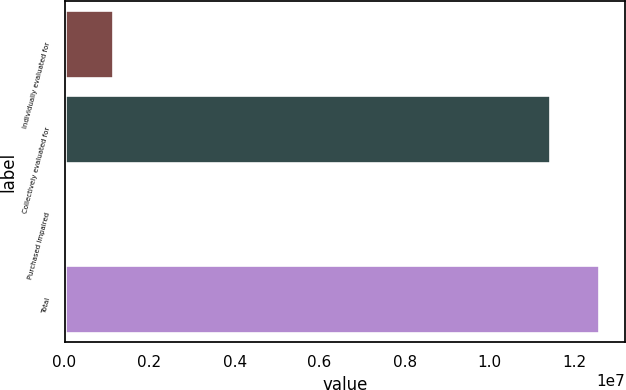Convert chart. <chart><loc_0><loc_0><loc_500><loc_500><bar_chart><fcel>Individually evaluated for<fcel>Collectively evaluated for<fcel>Purchased impaired<fcel>Total<nl><fcel>1.15098e+06<fcel>1.14141e+07<fcel>2366<fcel>1.25627e+07<nl></chart> 